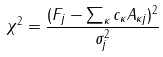Convert formula to latex. <formula><loc_0><loc_0><loc_500><loc_500>\chi ^ { 2 } = \frac { ( F _ { j } - \sum _ { \kappa } c _ { \kappa } A _ { \kappa j } ) ^ { 2 } } { \sigma _ { j } ^ { 2 } }</formula> 